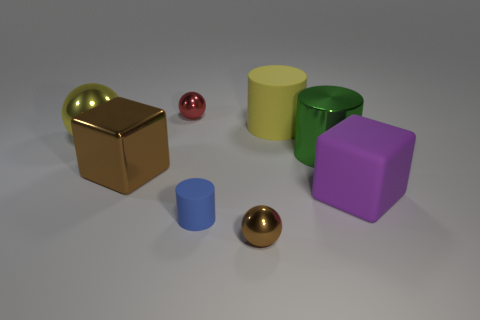Add 2 small red shiny balls. How many objects exist? 10 Subtract all spheres. How many objects are left? 5 Subtract all big shiny cylinders. Subtract all big purple cubes. How many objects are left? 6 Add 7 matte objects. How many matte objects are left? 10 Add 1 blue objects. How many blue objects exist? 2 Subtract 1 red balls. How many objects are left? 7 